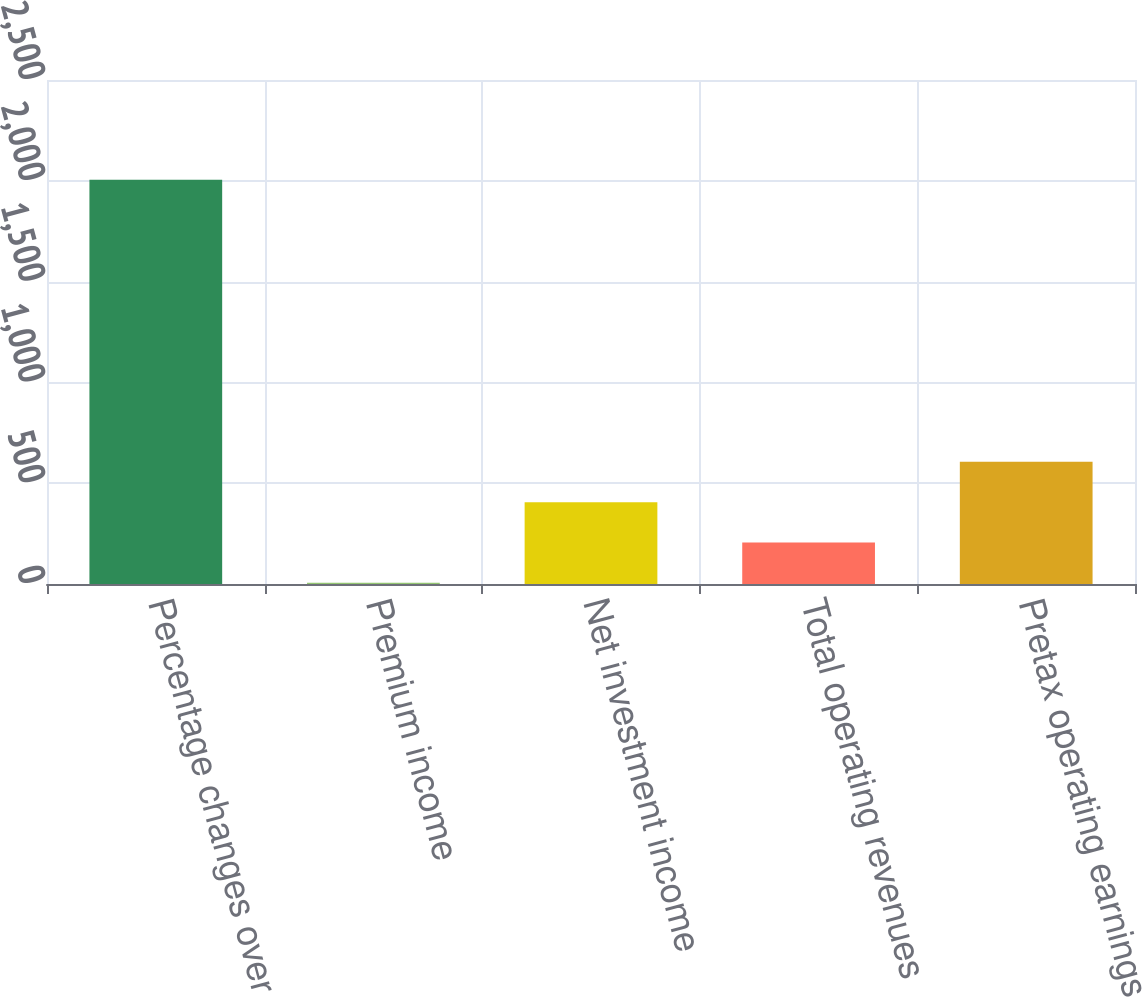<chart> <loc_0><loc_0><loc_500><loc_500><bar_chart><fcel>Percentage changes over<fcel>Premium income<fcel>Net investment income<fcel>Total operating revenues<fcel>Pretax operating earnings<nl><fcel>2005<fcel>6.3<fcel>406.04<fcel>206.17<fcel>605.91<nl></chart> 